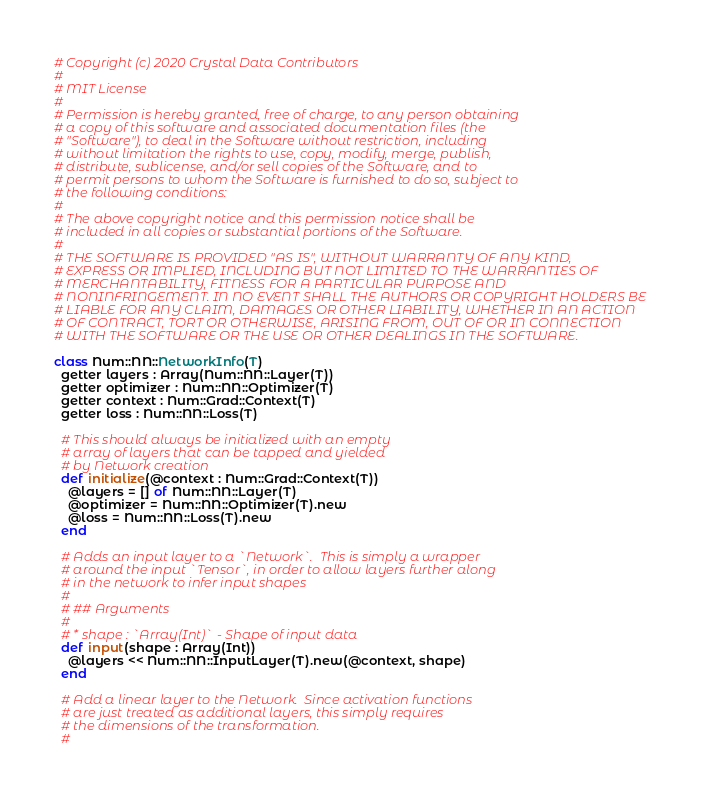Convert code to text. <code><loc_0><loc_0><loc_500><loc_500><_Crystal_># Copyright (c) 2020 Crystal Data Contributors
#
# MIT License
#
# Permission is hereby granted, free of charge, to any person obtaining
# a copy of this software and associated documentation files (the
# "Software"), to deal in the Software without restriction, including
# without limitation the rights to use, copy, modify, merge, publish,
# distribute, sublicense, and/or sell copies of the Software, and to
# permit persons to whom the Software is furnished to do so, subject to
# the following conditions:
#
# The above copyright notice and this permission notice shall be
# included in all copies or substantial portions of the Software.
#
# THE SOFTWARE IS PROVIDED "AS IS", WITHOUT WARRANTY OF ANY KIND,
# EXPRESS OR IMPLIED, INCLUDING BUT NOT LIMITED TO THE WARRANTIES OF
# MERCHANTABILITY, FITNESS FOR A PARTICULAR PURPOSE AND
# NONINFRINGEMENT. IN NO EVENT SHALL THE AUTHORS OR COPYRIGHT HOLDERS BE
# LIABLE FOR ANY CLAIM, DAMAGES OR OTHER LIABILITY, WHETHER IN AN ACTION
# OF CONTRACT, TORT OR OTHERWISE, ARISING FROM, OUT OF OR IN CONNECTION
# WITH THE SOFTWARE OR THE USE OR OTHER DEALINGS IN THE SOFTWARE.

class Num::NN::NetworkInfo(T)
  getter layers : Array(Num::NN::Layer(T))
  getter optimizer : Num::NN::Optimizer(T)
  getter context : Num::Grad::Context(T)
  getter loss : Num::NN::Loss(T)

  # This should always be initialized with an empty
  # array of layers that can be tapped and yielded
  # by Network creation
  def initialize(@context : Num::Grad::Context(T))
    @layers = [] of Num::NN::Layer(T)
    @optimizer = Num::NN::Optimizer(T).new
    @loss = Num::NN::Loss(T).new
  end

  # Adds an input layer to a `Network`.  This is simply a wrapper
  # around the input `Tensor`, in order to allow layers further along
  # in the network to infer input shapes
  #
  # ## Arguments
  #
  # * shape : `Array(Int)` - Shape of input data
  def input(shape : Array(Int))
    @layers << Num::NN::InputLayer(T).new(@context, shape)
  end

  # Add a linear layer to the Network.  Since activation functions
  # are just treated as additional layers, this simply requires
  # the dimensions of the transformation.
  #</code> 